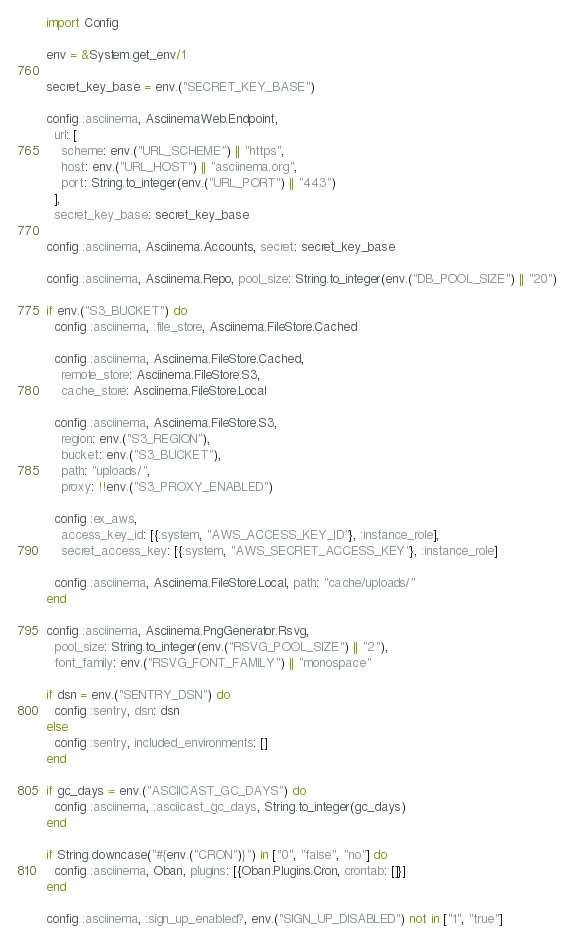<code> <loc_0><loc_0><loc_500><loc_500><_Elixir_>import Config

env = &System.get_env/1

secret_key_base = env.("SECRET_KEY_BASE")

config :asciinema, AsciinemaWeb.Endpoint,
  url: [
    scheme: env.("URL_SCHEME") || "https",
    host: env.("URL_HOST") || "asciinema.org",
    port: String.to_integer(env.("URL_PORT") || "443")
  ],
  secret_key_base: secret_key_base

config :asciinema, Asciinema.Accounts, secret: secret_key_base

config :asciinema, Asciinema.Repo, pool_size: String.to_integer(env.("DB_POOL_SIZE") || "20")

if env.("S3_BUCKET") do
  config :asciinema, :file_store, Asciinema.FileStore.Cached

  config :asciinema, Asciinema.FileStore.Cached,
    remote_store: Asciinema.FileStore.S3,
    cache_store: Asciinema.FileStore.Local

  config :asciinema, Asciinema.FileStore.S3,
    region: env.("S3_REGION"),
    bucket: env.("S3_BUCKET"),
    path: "uploads/",
    proxy: !!env.("S3_PROXY_ENABLED")

  config :ex_aws,
    access_key_id: [{:system, "AWS_ACCESS_KEY_ID"}, :instance_role],
    secret_access_key: [{:system, "AWS_SECRET_ACCESS_KEY"}, :instance_role]

  config :asciinema, Asciinema.FileStore.Local, path: "cache/uploads/"
end

config :asciinema, Asciinema.PngGenerator.Rsvg,
  pool_size: String.to_integer(env.("RSVG_POOL_SIZE") || "2"),
  font_family: env.("RSVG_FONT_FAMILY") || "monospace"

if dsn = env.("SENTRY_DSN") do
  config :sentry, dsn: dsn
else
  config :sentry, included_environments: []
end

if gc_days = env.("ASCIICAST_GC_DAYS") do
  config :asciinema, :asciicast_gc_days, String.to_integer(gc_days)
end

if String.downcase("#{env.("CRON")}") in ["0", "false", "no"] do
  config :asciinema, Oban, plugins: [{Oban.Plugins.Cron, crontab: []}]
end

config :asciinema, :sign_up_enabled?, env.("SIGN_UP_DISABLED") not in ["1", "true"]
</code> 